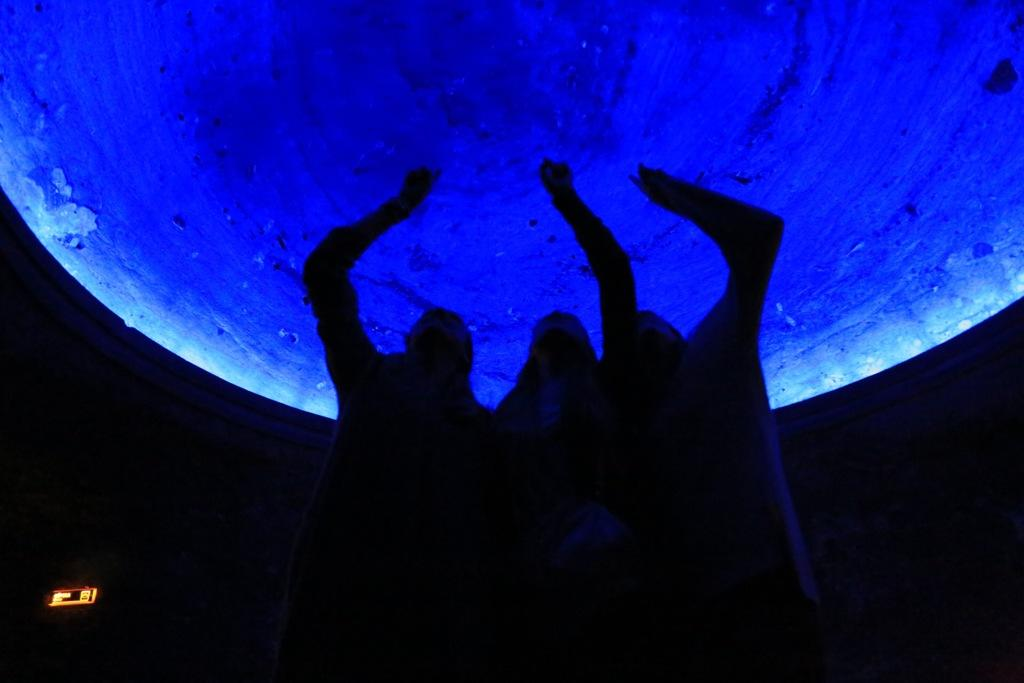How many people are in the image? There are three people in the image. What are the people doing in the image? The people are standing and touching a circular object. Can you describe the circular object in the image? The circular object is present in the image, but its specific details are not mentioned in the facts. What is the lighting condition in the image? The image is dark. What time of day is it in the image, and how does that affect the people's hearing? The time of day is not mentioned in the facts, and there is no information about the people's hearing. Therefore, we cannot determine the time of day or how it might affect their hearing. 